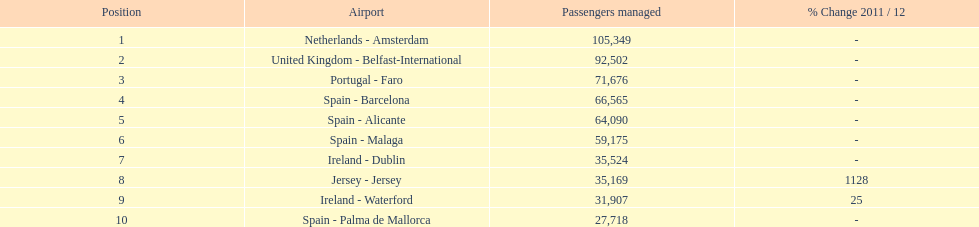Between the topped ranked airport, netherlands - amsterdam, & spain - palma de mallorca, what is the difference in the amount of passengers handled? 77,631. 